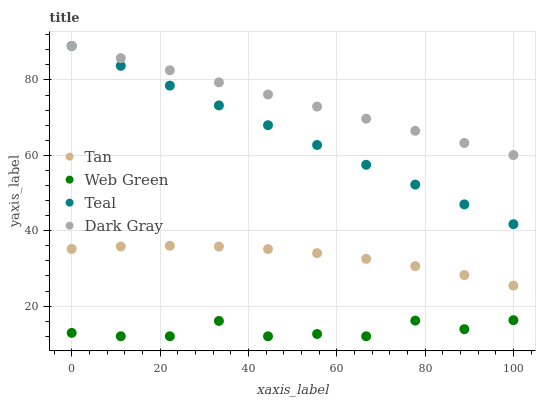Does Web Green have the minimum area under the curve?
Answer yes or no. Yes. Does Dark Gray have the maximum area under the curve?
Answer yes or no. Yes. Does Tan have the minimum area under the curve?
Answer yes or no. No. Does Tan have the maximum area under the curve?
Answer yes or no. No. Is Teal the smoothest?
Answer yes or no. Yes. Is Web Green the roughest?
Answer yes or no. Yes. Is Tan the smoothest?
Answer yes or no. No. Is Tan the roughest?
Answer yes or no. No. Does Web Green have the lowest value?
Answer yes or no. Yes. Does Tan have the lowest value?
Answer yes or no. No. Does Teal have the highest value?
Answer yes or no. Yes. Does Tan have the highest value?
Answer yes or no. No. Is Web Green less than Dark Gray?
Answer yes or no. Yes. Is Dark Gray greater than Tan?
Answer yes or no. Yes. Does Dark Gray intersect Teal?
Answer yes or no. Yes. Is Dark Gray less than Teal?
Answer yes or no. No. Is Dark Gray greater than Teal?
Answer yes or no. No. Does Web Green intersect Dark Gray?
Answer yes or no. No. 